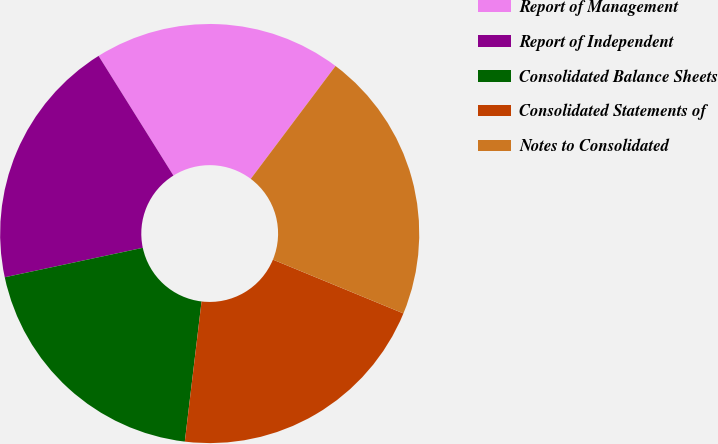Convert chart to OTSL. <chart><loc_0><loc_0><loc_500><loc_500><pie_chart><fcel>Report of Management<fcel>Report of Independent<fcel>Consolidated Balance Sheets<fcel>Consolidated Statements of<fcel>Notes to Consolidated<nl><fcel>19.15%<fcel>19.45%<fcel>19.76%<fcel>20.67%<fcel>20.97%<nl></chart> 